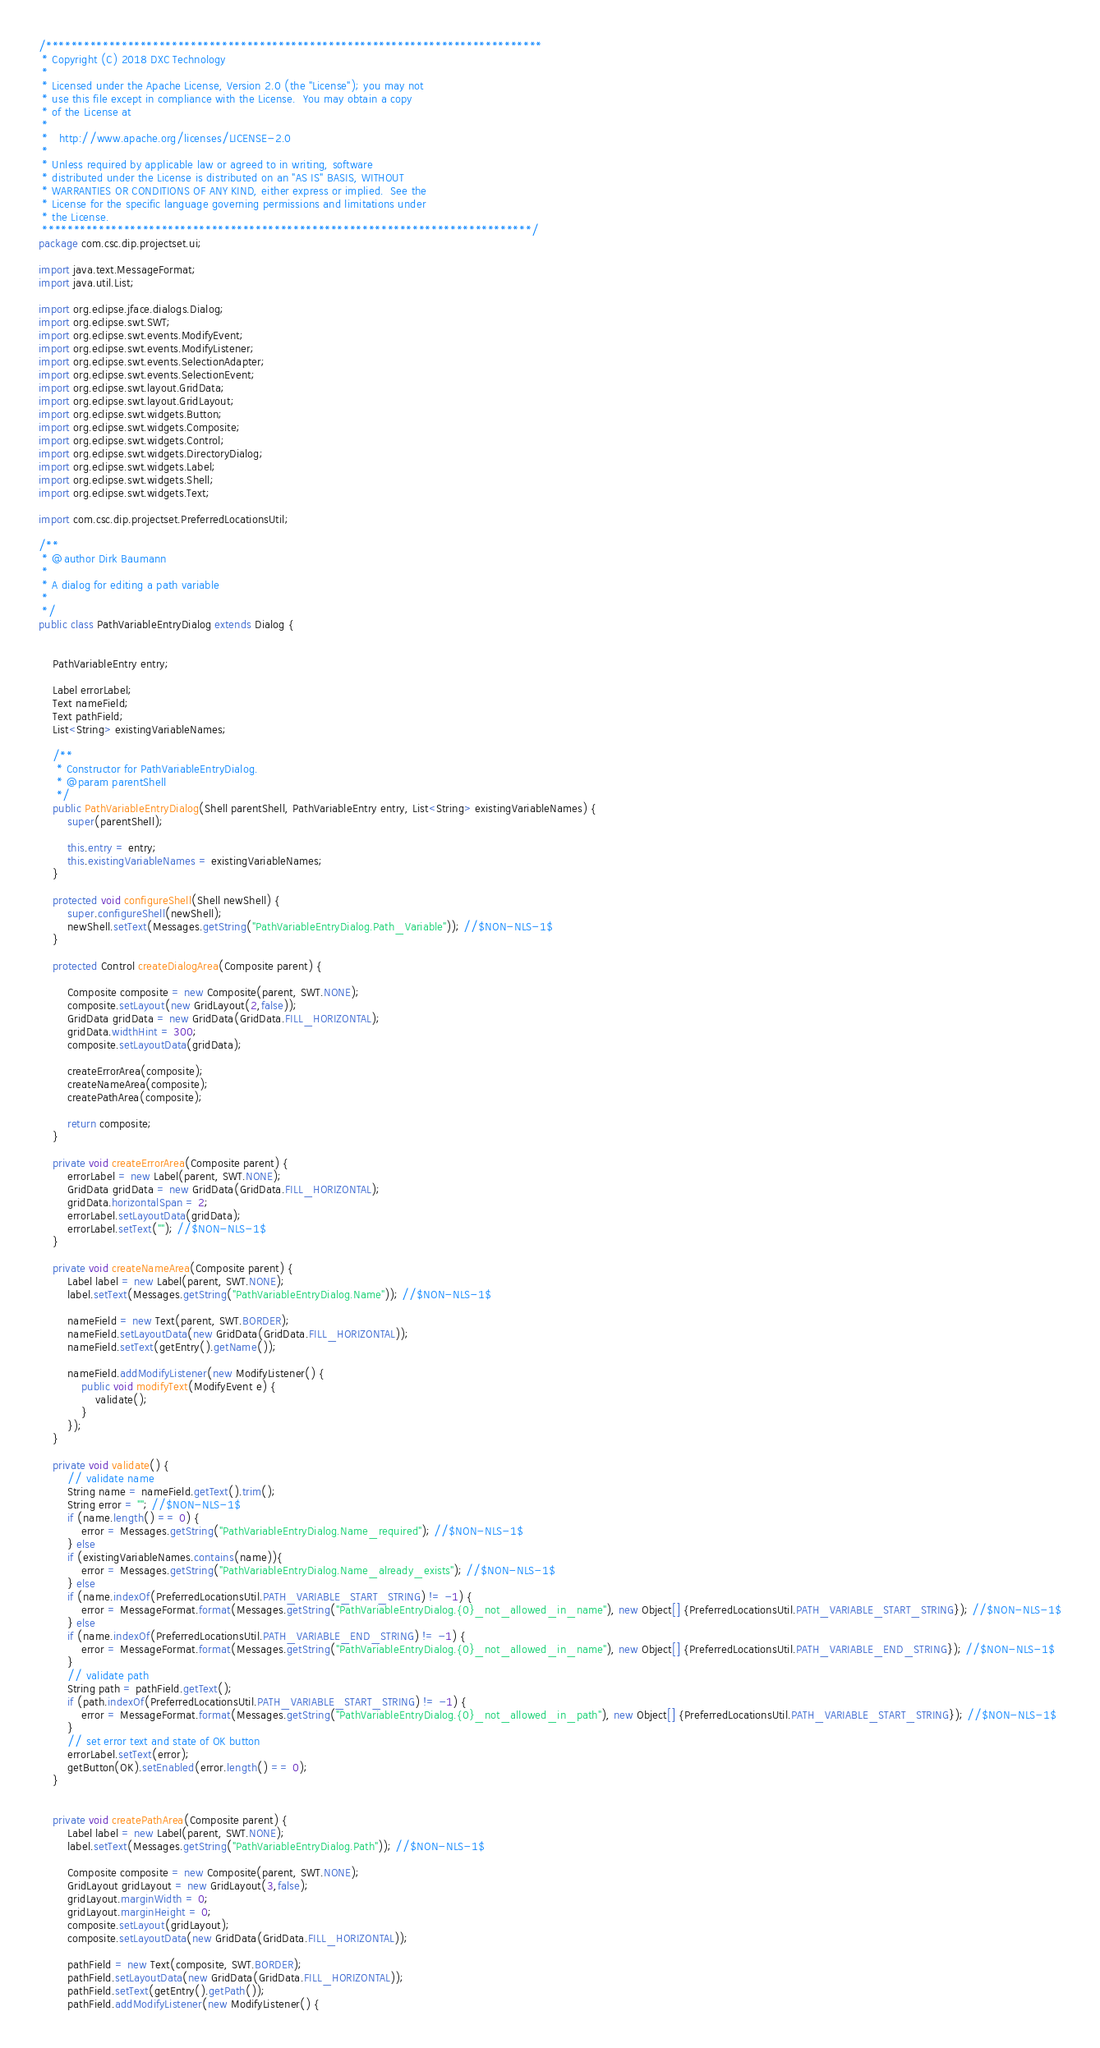Convert code to text. <code><loc_0><loc_0><loc_500><loc_500><_Java_>/*******************************************************************************
 * Copyright (C) 2018 DXC Technology
 * 
 * Licensed under the Apache License, Version 2.0 (the "License"); you may not
 * use this file except in compliance with the License.  You may obtain a copy
 * of the License at
 * 
 *   http://www.apache.org/licenses/LICENSE-2.0
 * 
 * Unless required by applicable law or agreed to in writing, software
 * distributed under the License is distributed on an "AS IS" BASIS, WITHOUT
 * WARRANTIES OR CONDITIONS OF ANY KIND, either express or implied.  See the
 * License for the specific language governing permissions and limitations under
 * the License.
 ******************************************************************************/
package com.csc.dip.projectset.ui;

import java.text.MessageFormat;
import java.util.List;

import org.eclipse.jface.dialogs.Dialog;
import org.eclipse.swt.SWT;
import org.eclipse.swt.events.ModifyEvent;
import org.eclipse.swt.events.ModifyListener;
import org.eclipse.swt.events.SelectionAdapter;
import org.eclipse.swt.events.SelectionEvent;
import org.eclipse.swt.layout.GridData;
import org.eclipse.swt.layout.GridLayout;
import org.eclipse.swt.widgets.Button;
import org.eclipse.swt.widgets.Composite;
import org.eclipse.swt.widgets.Control;
import org.eclipse.swt.widgets.DirectoryDialog;
import org.eclipse.swt.widgets.Label;
import org.eclipse.swt.widgets.Shell;
import org.eclipse.swt.widgets.Text;

import com.csc.dip.projectset.PreferredLocationsUtil;

/**
 * @author Dirk Baumann
 * 
 * A dialog for editing a path variable
 *
 */
public class PathVariableEntryDialog extends Dialog {


	PathVariableEntry entry;

	Label errorLabel;
	Text nameField;
	Text pathField;
	List<String> existingVariableNames;
	
	/**
	 * Constructor for PathVariableEntryDialog.
	 * @param parentShell
	 */
	public PathVariableEntryDialog(Shell parentShell, PathVariableEntry entry, List<String> existingVariableNames) {
		super(parentShell);
		
		this.entry = entry;
		this.existingVariableNames = existingVariableNames;
	}

	protected void configureShell(Shell newShell) {
		super.configureShell(newShell);
		newShell.setText(Messages.getString("PathVariableEntryDialog.Path_Variable")); //$NON-NLS-1$
	}
	
	protected Control createDialogArea(Composite parent) {
 
 		Composite composite = new Composite(parent, SWT.NONE);
		composite.setLayout(new GridLayout(2,false));
		GridData gridData = new GridData(GridData.FILL_HORIZONTAL);
		gridData.widthHint = 300;
		composite.setLayoutData(gridData);
		
		createErrorArea(composite);
		createNameArea(composite);
		createPathArea(composite);
				
 		return composite;
	}

	private void createErrorArea(Composite parent) {
		errorLabel = new Label(parent, SWT.NONE);
		GridData gridData = new GridData(GridData.FILL_HORIZONTAL);
		gridData.horizontalSpan = 2;
		errorLabel.setLayoutData(gridData);
		errorLabel.setText(""); //$NON-NLS-1$
	}

	private void createNameArea(Composite parent) {		
		Label label = new Label(parent, SWT.NONE);
		label.setText(Messages.getString("PathVariableEntryDialog.Name")); //$NON-NLS-1$
		
		nameField = new Text(parent, SWT.BORDER);
		nameField.setLayoutData(new GridData(GridData.FILL_HORIZONTAL));
		nameField.setText(getEntry().getName());
		
		nameField.addModifyListener(new ModifyListener() {
			public void modifyText(ModifyEvent e) {
				validate();
			}
		});
	}

	private void validate() {
		// validate name
		String name = nameField.getText().trim();
		String error = ""; //$NON-NLS-1$
		if (name.length() == 0) {
			error = Messages.getString("PathVariableEntryDialog.Name_required"); //$NON-NLS-1$
		} else
		if (existingVariableNames.contains(name)){
			error = Messages.getString("PathVariableEntryDialog.Name_already_exists"); //$NON-NLS-1$
		} else
		if (name.indexOf(PreferredLocationsUtil.PATH_VARIABLE_START_STRING) != -1) {
			error = MessageFormat.format(Messages.getString("PathVariableEntryDialog.{0}_not_allowed_in_name"), new Object[] {PreferredLocationsUtil.PATH_VARIABLE_START_STRING}); //$NON-NLS-1$
		} else
		if (name.indexOf(PreferredLocationsUtil.PATH_VARIABLE_END_STRING) != -1) {
			error = MessageFormat.format(Messages.getString("PathVariableEntryDialog.{0}_not_allowed_in_name"), new Object[] {PreferredLocationsUtil.PATH_VARIABLE_END_STRING}); //$NON-NLS-1$
		}
		// validate path
		String path = pathField.getText();
		if (path.indexOf(PreferredLocationsUtil.PATH_VARIABLE_START_STRING) != -1) {
			error = MessageFormat.format(Messages.getString("PathVariableEntryDialog.{0}_not_allowed_in_path"), new Object[] {PreferredLocationsUtil.PATH_VARIABLE_START_STRING}); //$NON-NLS-1$
		}		
		// set error text and state of OK button
		errorLabel.setText(error);
		getButton(OK).setEnabled(error.length() == 0);
	}


	private void createPathArea(Composite parent) {
		Label label = new Label(parent, SWT.NONE);
		label.setText(Messages.getString("PathVariableEntryDialog.Path")); //$NON-NLS-1$

		Composite composite = new Composite(parent, SWT.NONE);
		GridLayout gridLayout = new GridLayout(3,false);
		gridLayout.marginWidth = 0;
		gridLayout.marginHeight = 0;
		composite.setLayout(gridLayout);
		composite.setLayoutData(new GridData(GridData.FILL_HORIZONTAL));
		
		pathField = new Text(composite, SWT.BORDER);
		pathField.setLayoutData(new GridData(GridData.FILL_HORIZONTAL));
		pathField.setText(getEntry().getPath());
		pathField.addModifyListener(new ModifyListener() {</code> 